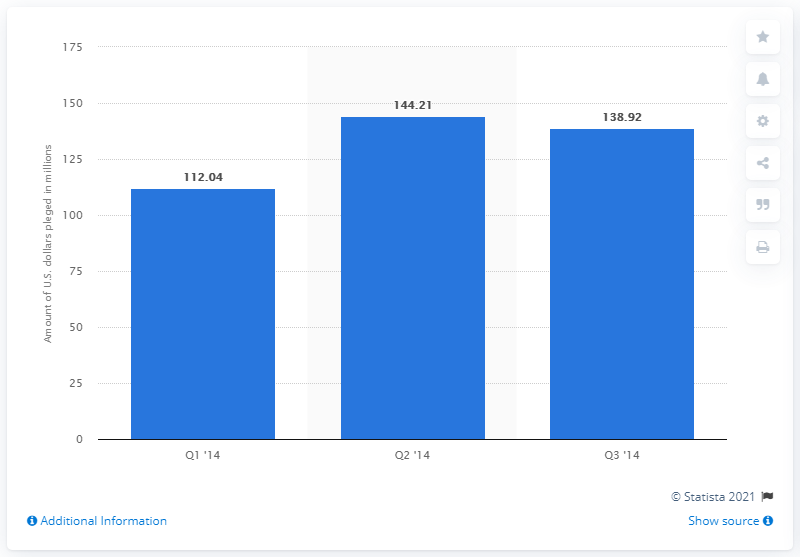Outline some significant characteristics in this image. The difference between quarter 2 and quarter 3 is less than or equal to 10. In the first quarter of 2014, the Kickstarter project generated a total of 112.04 million USD. During the third quarter of 2014, a total of 138.92 dollars were pledged to projects on the crowdfunding platform. 